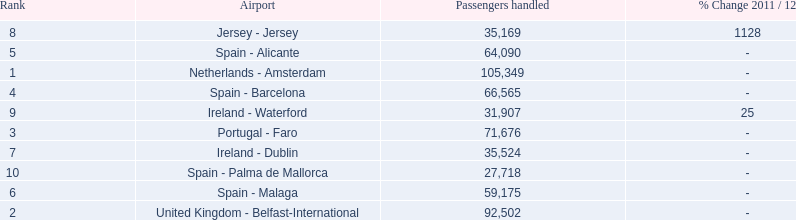What is the highest number of passengers handled? 105,349. What is the destination of the passengers leaving the area that handles 105,349 travellers? Netherlands - Amsterdam. 